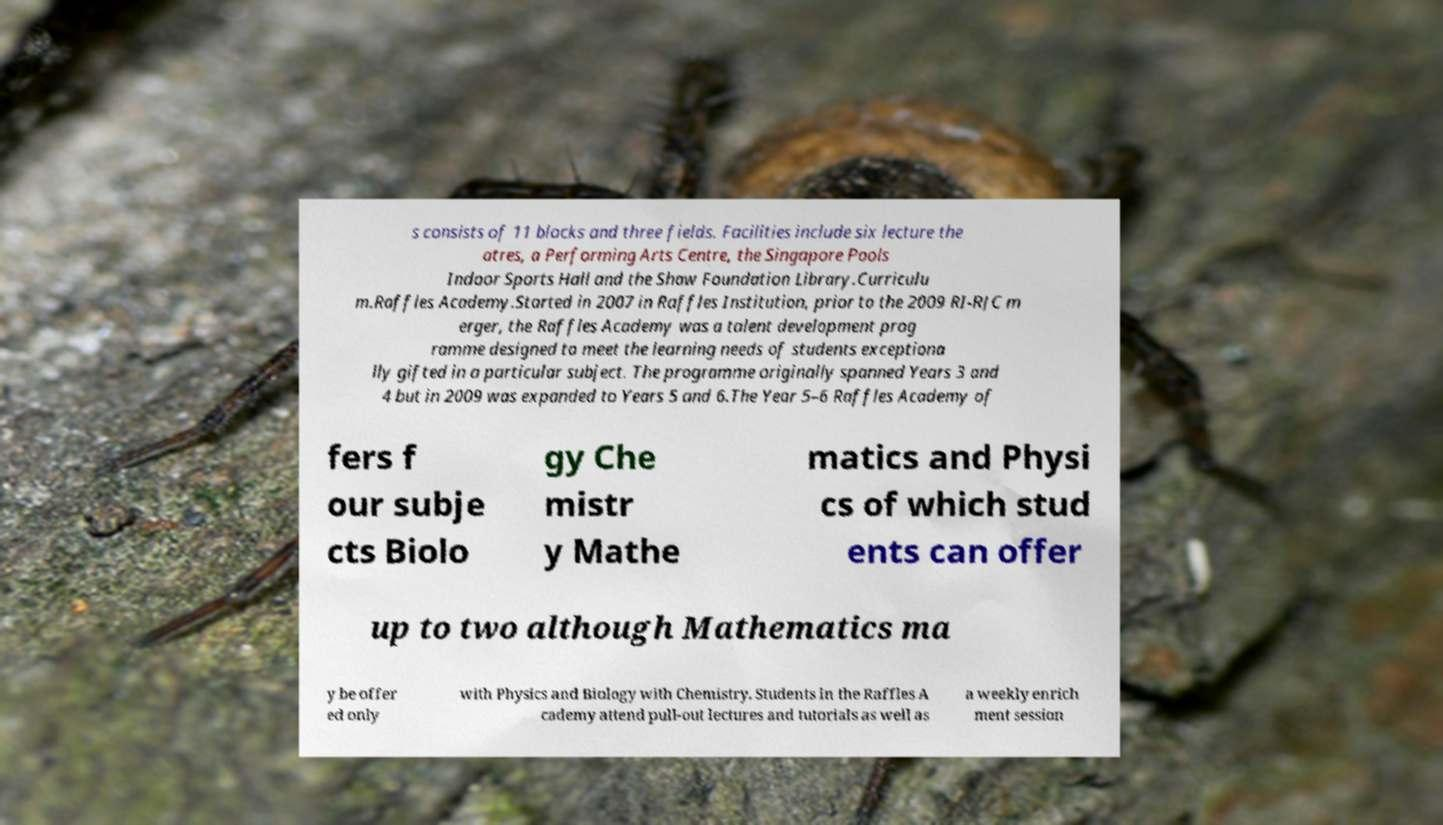Please read and relay the text visible in this image. What does it say? s consists of 11 blocks and three fields. Facilities include six lecture the atres, a Performing Arts Centre, the Singapore Pools Indoor Sports Hall and the Shaw Foundation Library.Curriculu m.Raffles Academy.Started in 2007 in Raffles Institution, prior to the 2009 RI-RJC m erger, the Raffles Academy was a talent development prog ramme designed to meet the learning needs of students exceptiona lly gifted in a particular subject. The programme originally spanned Years 3 and 4 but in 2009 was expanded to Years 5 and 6.The Year 5–6 Raffles Academy of fers f our subje cts Biolo gy Che mistr y Mathe matics and Physi cs of which stud ents can offer up to two although Mathematics ma y be offer ed only with Physics and Biology with Chemistry. Students in the Raffles A cademy attend pull-out lectures and tutorials as well as a weekly enrich ment session 